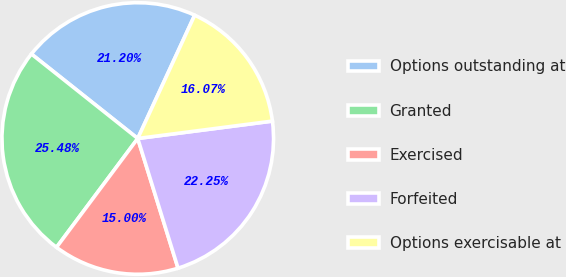Convert chart to OTSL. <chart><loc_0><loc_0><loc_500><loc_500><pie_chart><fcel>Options outstanding at<fcel>Granted<fcel>Exercised<fcel>Forfeited<fcel>Options exercisable at<nl><fcel>21.2%<fcel>25.48%<fcel>15.0%<fcel>22.25%<fcel>16.07%<nl></chart> 